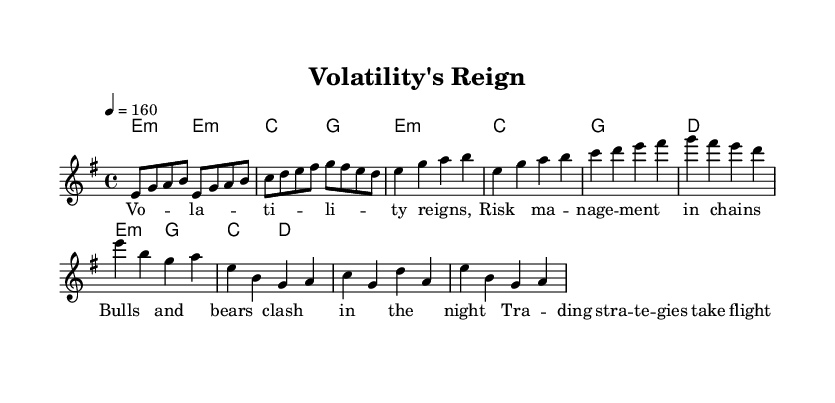What is the key signature of this music? The key signature indicated is E minor, which is portrayed in the global section at the beginning of the score. E minor has one sharp, F sharp.
Answer: E minor What is the time signature of this music? The time signature is 4/4, which is also specified in the global section of the score. This means there are four beats in each measure and a quarter note receives one beat.
Answer: 4/4 What is the tempo marking for this piece? The tempo marking states "4 = 160," indicating that there are 160 quarter note beats per minute. This is a relatively fast tempo, suitable for the energetic style of power metal.
Answer: 160 How many measures are there in the chorus? The chorus consists of four measures, as observed in the melody section where it is specified. Each measure contains a defined number of notes, clearly indicating the structure.
Answer: 4 Which chord is played in the first measure? The first measure features the E minor chord, as indicated in the harmonies section. This can be confirmed by referencing the chord mode where it starts with E minor and is sustained for two beats.
Answer: E minor What is the thematic focus of the lyrics? The thematic focus of the lyrics revolves around financial market concepts, specifically volatility and risk management, as represented in the phrases that include keywords like "risk" and "trading strategies."
Answer: Volatility and risk management 